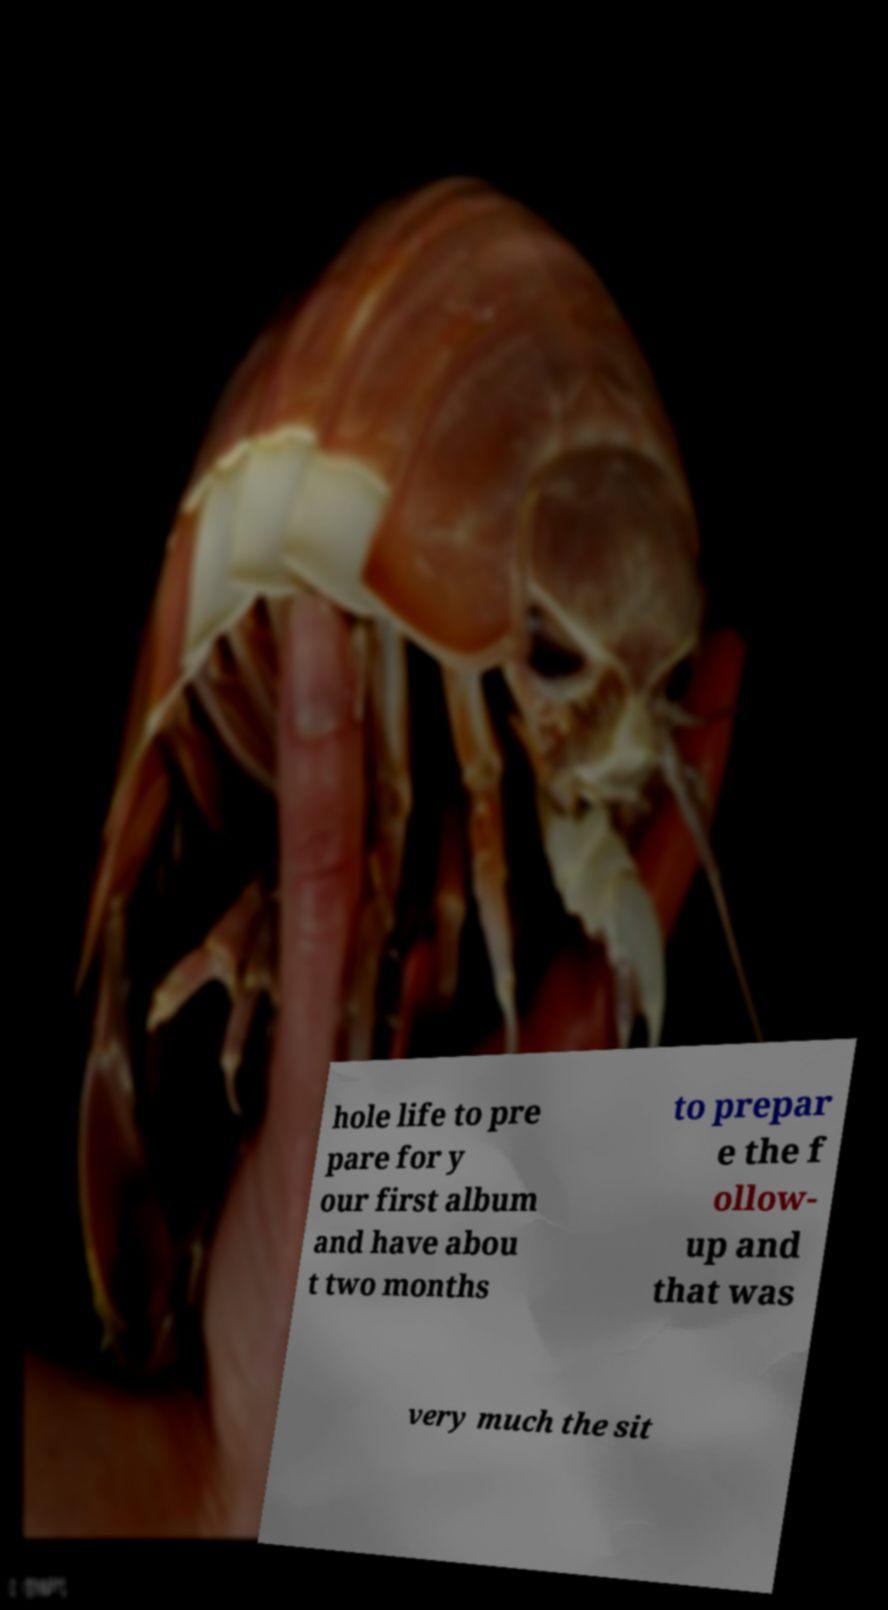Could you assist in decoding the text presented in this image and type it out clearly? hole life to pre pare for y our first album and have abou t two months to prepar e the f ollow- up and that was very much the sit 